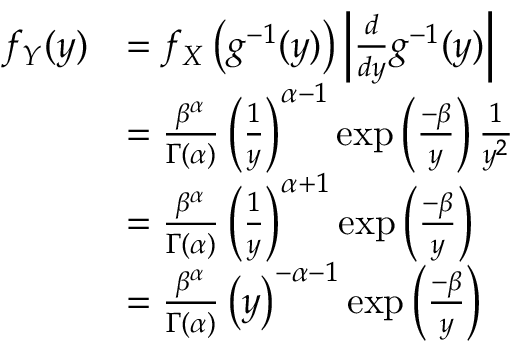Convert formula to latex. <formula><loc_0><loc_0><loc_500><loc_500>{ \begin{array} { r l } { f _ { Y } ( y ) } & { = f _ { X } \left ( g ^ { - 1 } ( y ) \right ) \left | { \frac { d } { d y } } g ^ { - 1 } ( y ) \right | } \\ & { = { \frac { \beta ^ { \alpha } } { \Gamma ( \alpha ) } } \left ( { \frac { 1 } { y } } \right ) ^ { \alpha - 1 } \exp \left ( { \frac { - \beta } { y } } \right ) { \frac { 1 } { y ^ { 2 } } } } \\ & { = { \frac { \beta ^ { \alpha } } { \Gamma ( \alpha ) } } \left ( { \frac { 1 } { y } } \right ) ^ { \alpha + 1 } \exp \left ( { \frac { - \beta } { y } } \right ) } \\ & { = { \frac { \beta ^ { \alpha } } { \Gamma ( \alpha ) } } \left ( y \right ) ^ { - \alpha - 1 } \exp \left ( { \frac { - \beta } { y } } \right ) } \end{array} }</formula> 